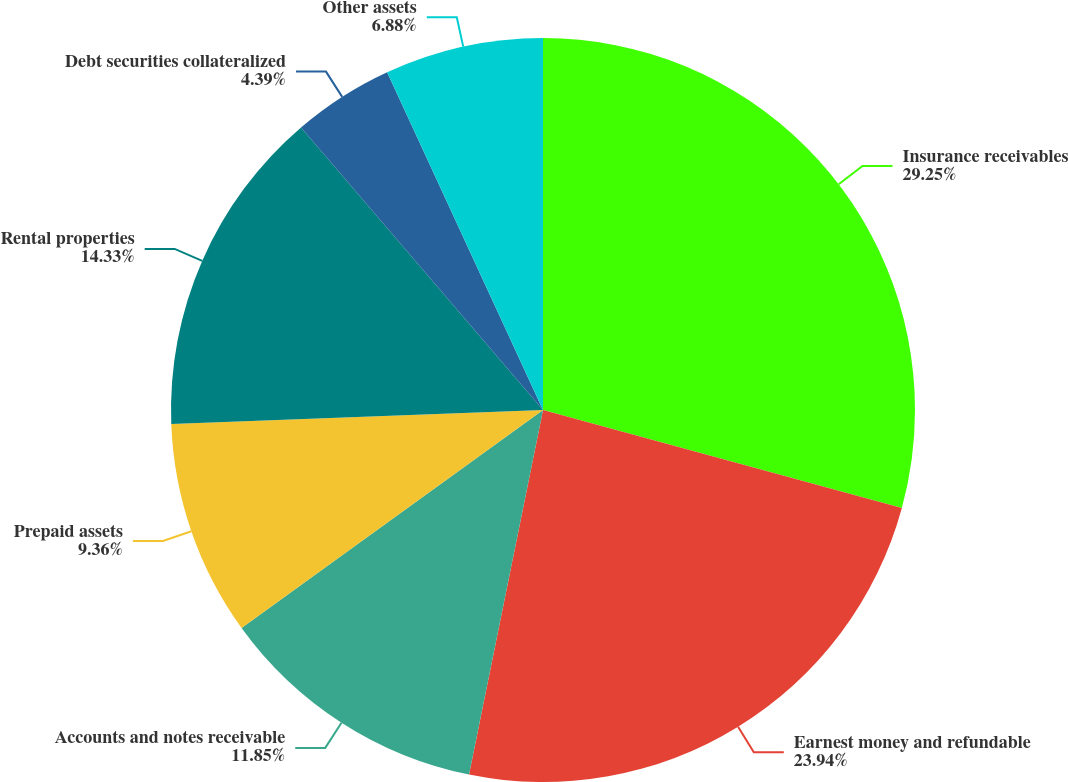Convert chart to OTSL. <chart><loc_0><loc_0><loc_500><loc_500><pie_chart><fcel>Insurance receivables<fcel>Earnest money and refundable<fcel>Accounts and notes receivable<fcel>Prepaid assets<fcel>Rental properties<fcel>Debt securities collateralized<fcel>Other assets<nl><fcel>29.24%<fcel>23.94%<fcel>11.85%<fcel>9.36%<fcel>14.33%<fcel>4.39%<fcel>6.88%<nl></chart> 